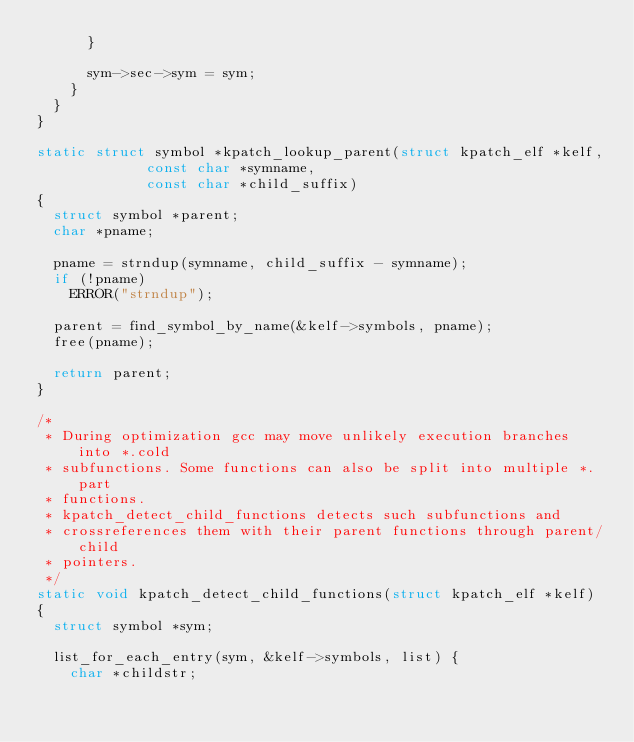Convert code to text. <code><loc_0><loc_0><loc_500><loc_500><_C_>			}

			sym->sec->sym = sym;
		}
	}
}

static struct symbol *kpatch_lookup_parent(struct kpatch_elf *kelf,
					   const char *symname,
					   const char *child_suffix)
{
	struct symbol *parent;
	char *pname;

	pname = strndup(symname, child_suffix - symname);
	if (!pname)
		ERROR("strndup");

	parent = find_symbol_by_name(&kelf->symbols, pname);
	free(pname);

	return parent;
}

/*
 * During optimization gcc may move unlikely execution branches into *.cold
 * subfunctions. Some functions can also be split into multiple *.part
 * functions.
 * kpatch_detect_child_functions detects such subfunctions and
 * crossreferences them with their parent functions through parent/child
 * pointers.
 */
static void kpatch_detect_child_functions(struct kpatch_elf *kelf)
{
	struct symbol *sym;

	list_for_each_entry(sym, &kelf->symbols, list) {
		char *childstr;
</code> 